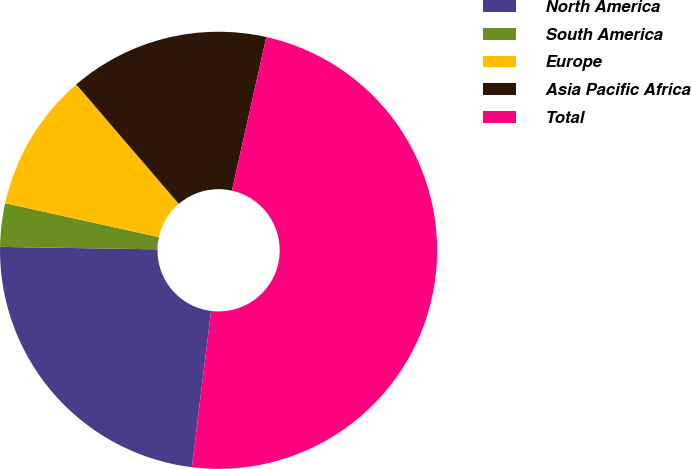Convert chart to OTSL. <chart><loc_0><loc_0><loc_500><loc_500><pie_chart><fcel>North America<fcel>South America<fcel>Europe<fcel>Asia Pacific Africa<fcel>Total<nl><fcel>23.3%<fcel>3.21%<fcel>10.26%<fcel>14.79%<fcel>48.45%<nl></chart> 